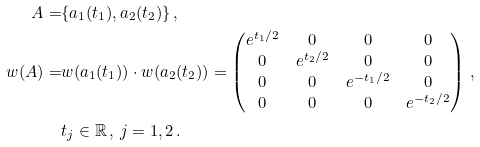Convert formula to latex. <formula><loc_0><loc_0><loc_500><loc_500>A = & \{ a _ { 1 } ( t _ { 1 } ) , a _ { 2 } ( t _ { 2 } ) \} \, , \\ w ( A ) = & w ( a _ { 1 } ( t _ { 1 } ) ) \cdot w ( a _ { 2 } ( t _ { 2 } ) ) = \begin{pmatrix} e ^ { t _ { 1 } / 2 } & 0 & 0 & 0 \\ 0 & e ^ { t _ { 2 } / 2 } & 0 & 0 \\ 0 & 0 & e ^ { - t _ { 1 } / 2 } & 0 \\ 0 & 0 & 0 & e ^ { - t _ { 2 } / 2 } \end{pmatrix} \, , \\ & t _ { j } \in \mathbb { R } \, , \, j = 1 , 2 \, .</formula> 